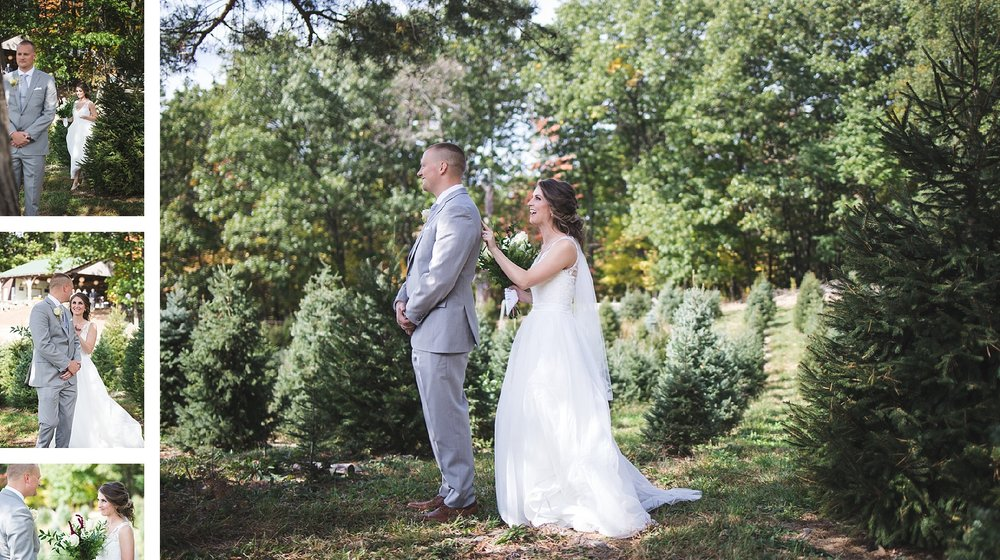Can you describe the style and theme of this wedding based on the image? The wedding depicted in the image appears to embrace a rustic and natural theme. This is evidenced by the outdoor setting amidst trees and greenery, suggesting a celebration that honors the beauty of nature. The bride's elegant yet straightforward dress, coupled with the groom's light grey suit, conveys a sense of relaxed formality. The overall impression is one of understated elegance and an appreciation for a serene, natural backdrop, making it intimate and personal. 